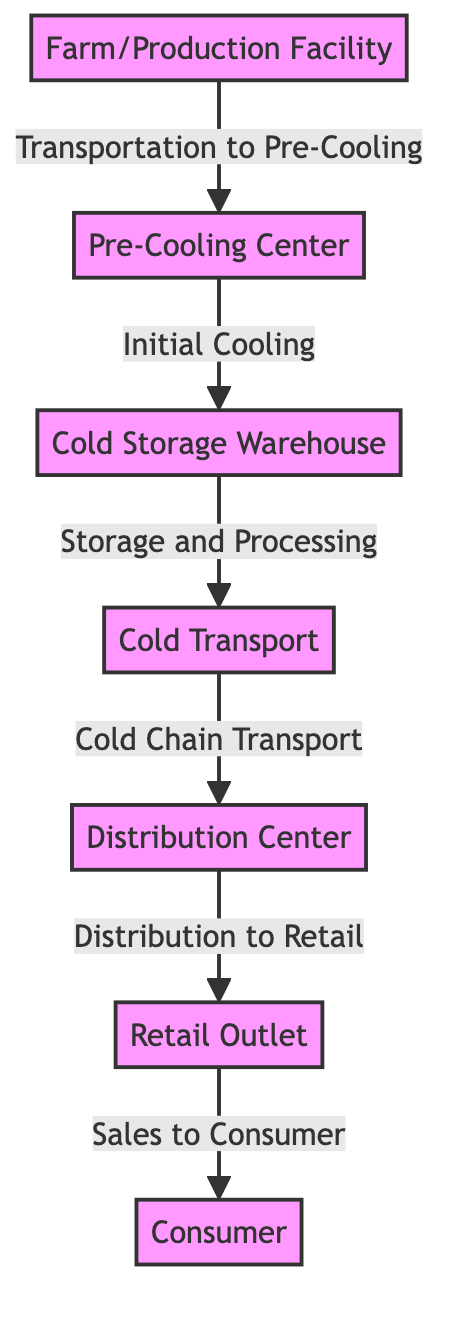What is the first node in the diagram? The first node is labeled "Farm/Production Facility," indicating where the food production begins in the cold chain logistics.
Answer: Farm/Production Facility How many nodes are present in the diagram? The diagram contains seven distinct nodes representing various stages in the cold chain logistics process from production to consumer.
Answer: 7 What is the last node in the flow? The last node is "Consumer," showing that the ultimate destination for the food in this logistics chain is the end-user.
Answer: Consumer What is the relationship between the "Cold Storage Warehouse" and "Cold Transport"? "Cold Storage Warehouse" is connected to "Cold Transport" with an edge labeled "Storage and Processing," indicating food items are processed and stored before being transported.
Answer: Storage and Processing How many edges connect the nodes in the diagram? There are six edges connecting the nodes, illustrating the flow of food through the various stages of cold chain logistics.
Answer: 6 Which node acts as the hub between distribution and retail? The node "Distribution Center" acts as the intermediary hub, facilitating the transfer between cold transport and retail outlet.
Answer: Distribution Center What process occurs after "Pre-Cooling Center"? The process after "Pre-Cooling Center" transitions to "Cold Storage Warehouse," indicating that cooled products are stored next.
Answer: Cold Storage Warehouse What does the arrow from "Cold Transport" to "Distribution Center" indicate? The arrow signifies the flow of goods from "Cold Transport" to "Distribution Center," illustrating the transportation of products maintained under cold conditions to the next stage of logistics.
Answer: Cold Chain Transport What stage comes directly before the "Retail Outlet"? The stage that precedes "Retail Outlet" is "Distribution Center," indicating that goods are distributed to retail from the central logistics hub.
Answer: Distribution Center 